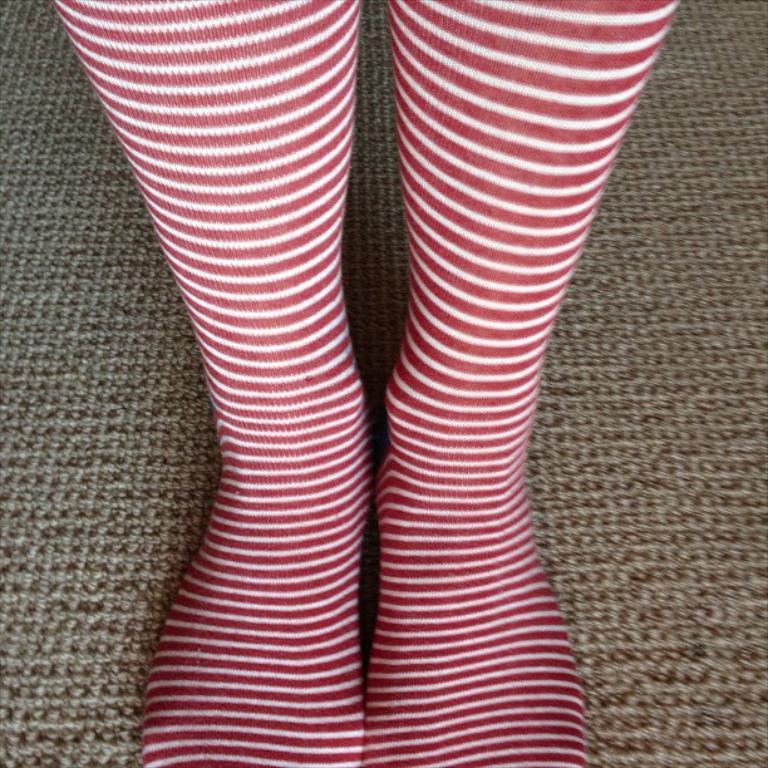What body parts are visible in the image? There are person's legs visible in the image. What type of flooring is present in the image? There is a carpet in the image. What type of game is being played in the image? There is no game visible in the image; only a person's legs and a carpet are present. 